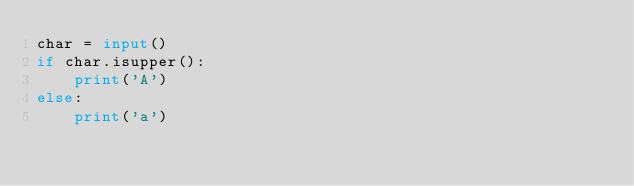<code> <loc_0><loc_0><loc_500><loc_500><_Python_>char = input()
if char.isupper():
    print('A')
else:
    print('a')</code> 